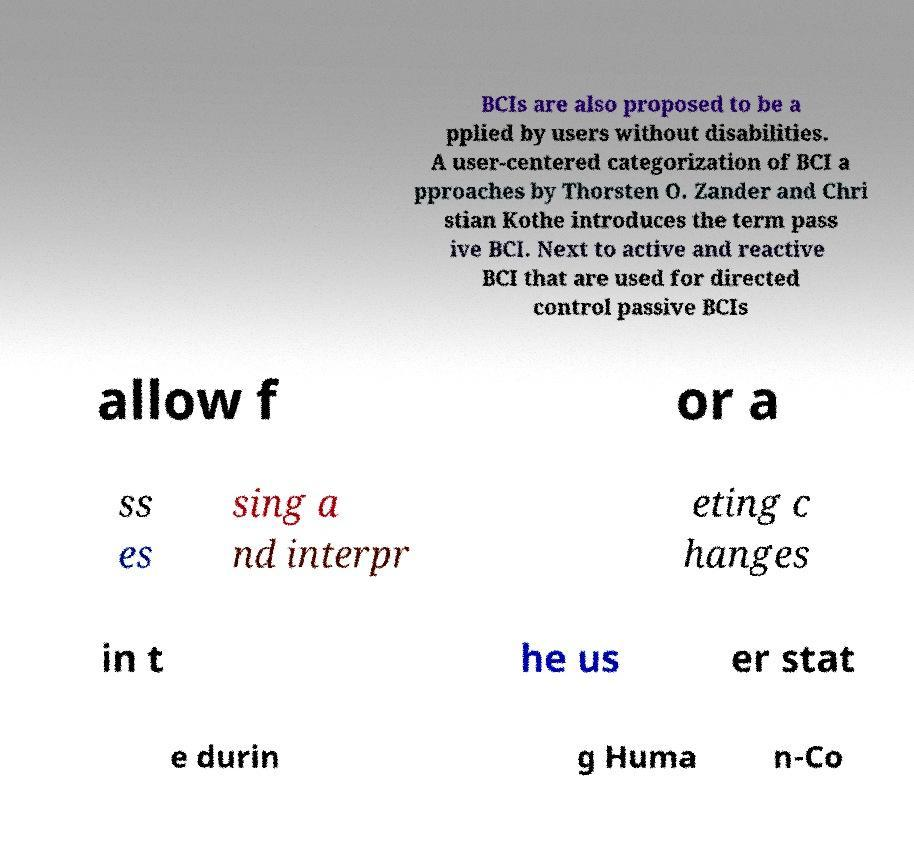What messages or text are displayed in this image? I need them in a readable, typed format. BCIs are also proposed to be a pplied by users without disabilities. A user-centered categorization of BCI a pproaches by Thorsten O. Zander and Chri stian Kothe introduces the term pass ive BCI. Next to active and reactive BCI that are used for directed control passive BCIs allow f or a ss es sing a nd interpr eting c hanges in t he us er stat e durin g Huma n-Co 